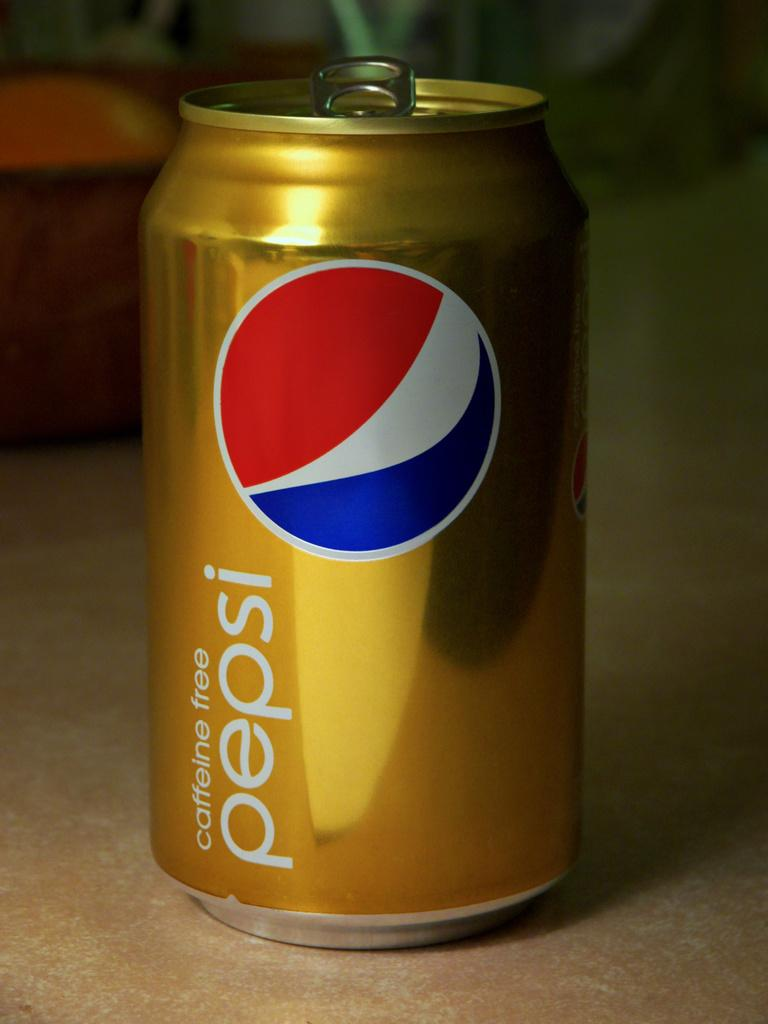<image>
Describe the image concisely. A close of of a gold can of Caffeine free Pepsi. 